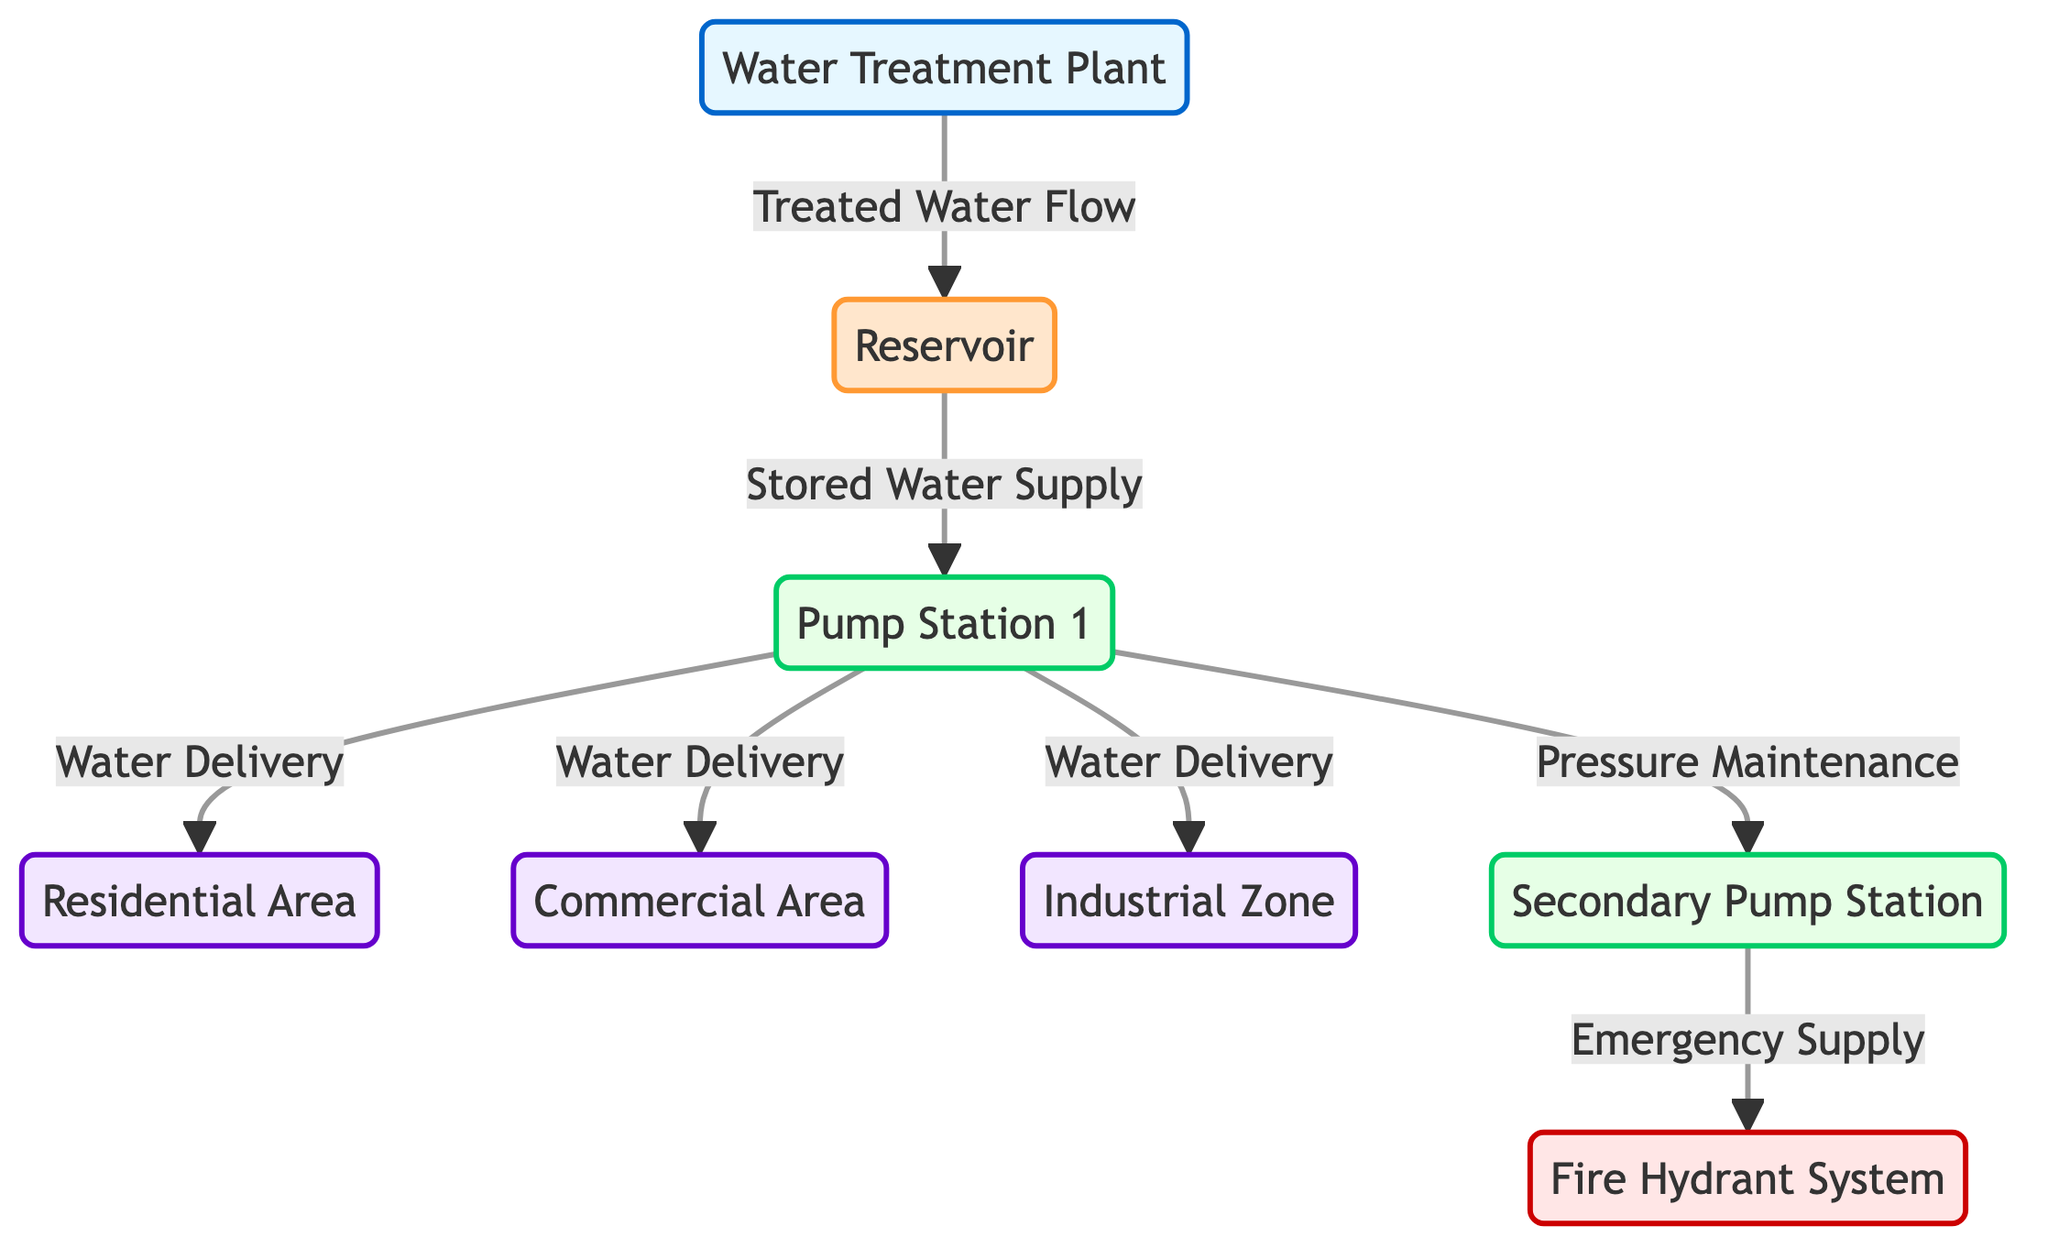What is the source of water in the network? The diagram shows that the water source in the network is the Water Treatment Plant, which provides treated water that flows into the Reservoir.
Answer: Water Treatment Plant How many areas receive water from Pump Station 1? By examining the diagram, we see that Pump Station 1 delivers water to three areas: Residential Area, Commercial Area, and Industrial Zone.
Answer: Three What connects the Reservoir and Pump Station 1? The diagram indicates that the connection between the Reservoir and Pump Station 1 is labeled as "Stored Water Supply." This denotes the flow path from the storage to the delivery system.
Answer: Stored Water Supply What is the function of the Secondary Pump Station? Looking closely at the flow interactions, the Secondary Pump Station serves the role of providing an "Emergency Supply" to the Fire Hydrant System, enhancing pressure and availability during emergencies.
Answer: Emergency Supply Which node is responsible for pressure maintenance? The diagram specifically states that Pump Station 1 has a dual role; besides delivering water, it also maintains pressure by connecting to the Secondary Pump Station.
Answer: Pump Station 1 What is the final destination of water from the Secondary Pump Station? According to the flow in the diagram, the final destination of water from the Secondary Pump Station is the Fire Hydrant System, which is critical in emergencies.
Answer: Fire Hydrant System How many types of areas are depicted in the diagram? The diagram includes three types of areas: Residential Area, Commercial Area, and Industrial Zone, summing up to three distinct types.
Answer: Three What type of node is the Water Treatment Plant? Based on the visual categorization in the diagram, the Water Treatment Plant is specifically defined as a "Plant," indicated by its color coding.
Answer: Plant 